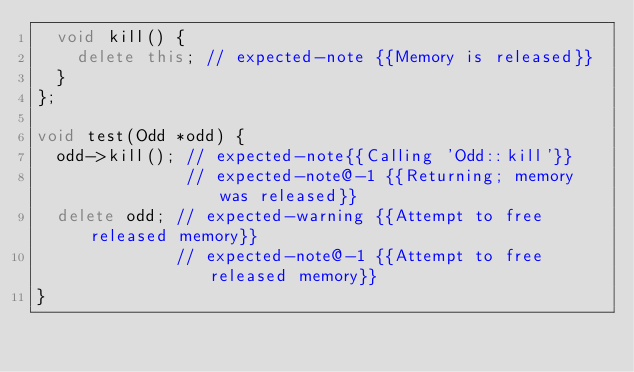Convert code to text. <code><loc_0><loc_0><loc_500><loc_500><_C++_>	void kill() {
		delete this; // expected-note {{Memory is released}}
	}
};

void test(Odd *odd) {
	odd->kill(); // expected-note{{Calling 'Odd::kill'}}
               // expected-note@-1 {{Returning; memory was released}}
	delete odd; // expected-warning {{Attempt to free released memory}}
              // expected-note@-1 {{Attempt to free released memory}}
}

</code> 